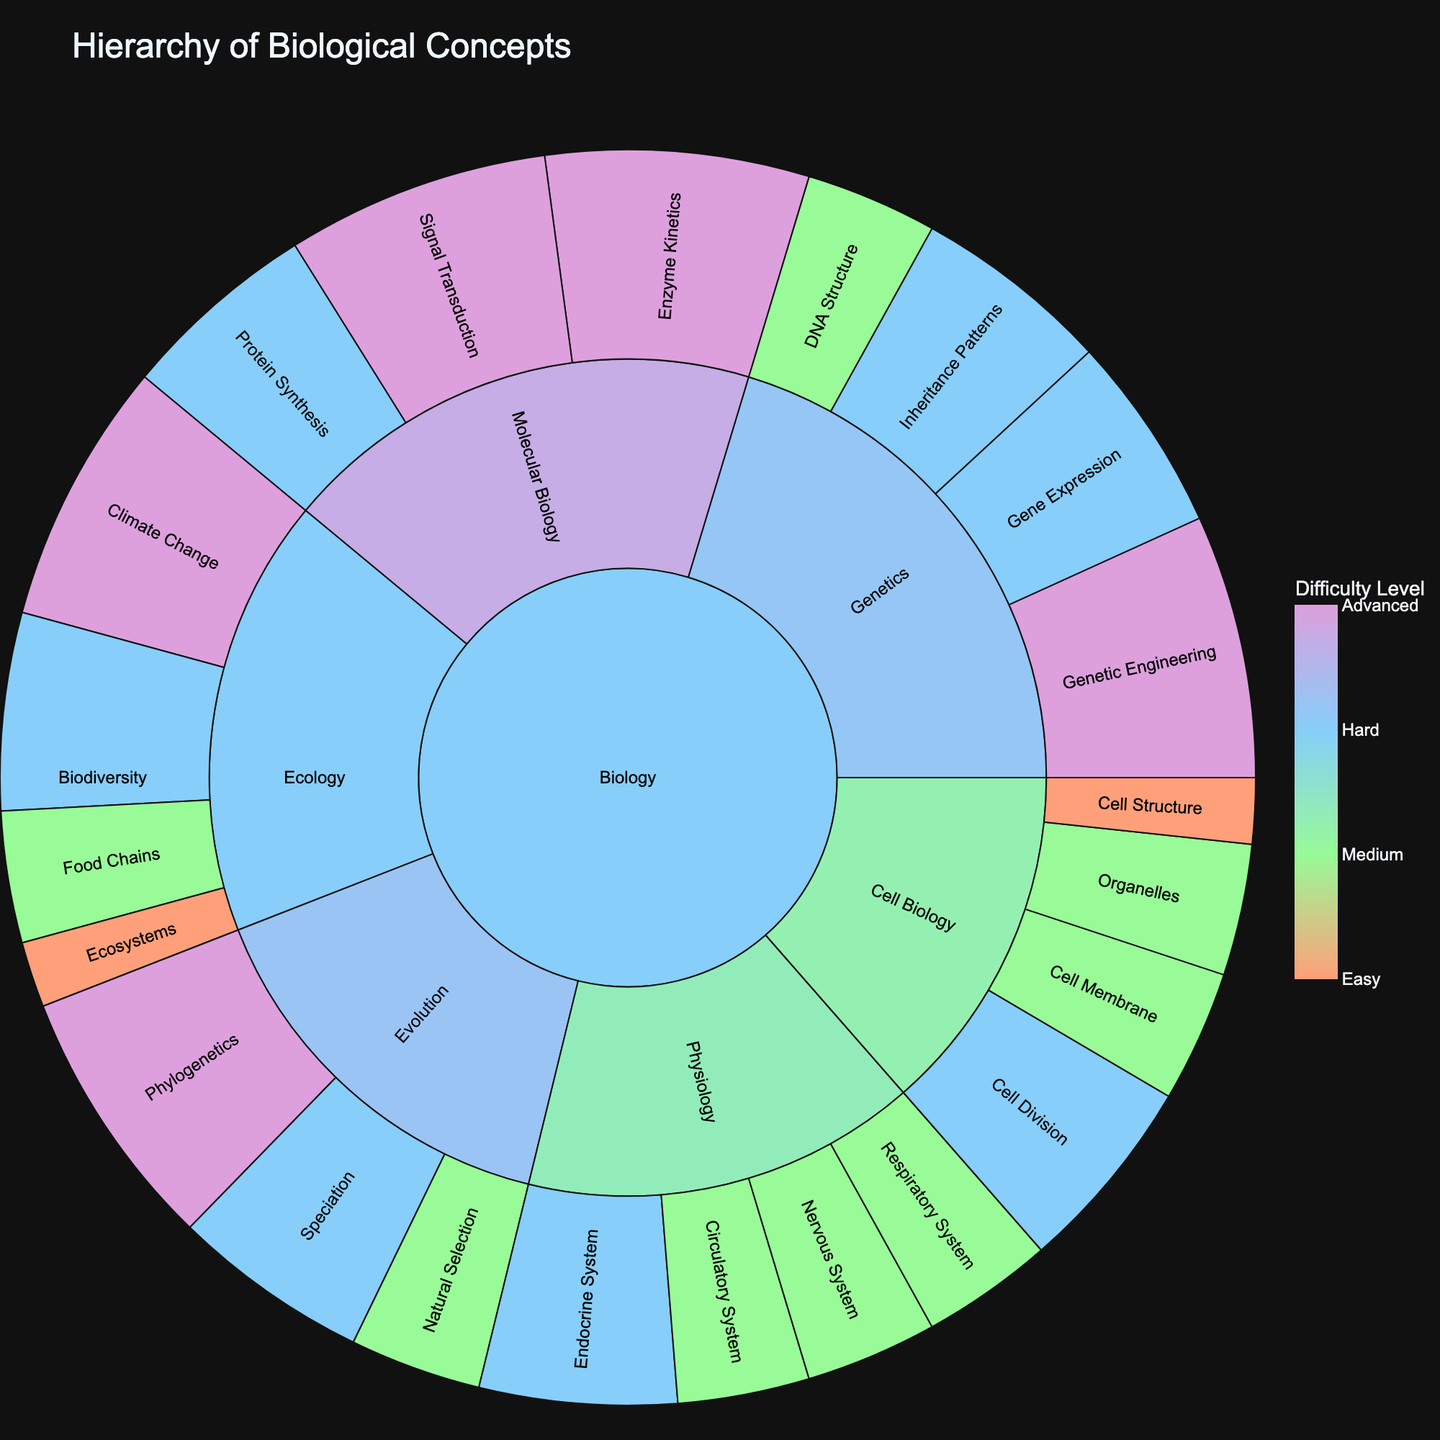What is the title of the plot? The title is usually found at the top of the plot, clearly indicating the subject or purpose of the visualization. Here, it appears as "Hierarchy of Biological Concepts".
Answer: Hierarchy of Biological Concepts How many main subject areas are represented in the plot? By examining the first level of the sunburst plot originating from the center, we see that there is only one main subject area, which is Biology.
Answer: 1 Which category has the most sub-concepts under it? To determine this, observe the categories branching out from the main subject and count the number of sub-concepts within each category. Cell Biology has the most sub-concepts, with 4 sub-concepts.
Answer: Cell Biology What is the highest difficulty level depicted in the plot? By looking at the color scale and the associated segments, we see that the highest difficulty level is labeled as 4, which corresponds to the darkest color in the color scale.
Answer: 4 Which conceptual category under Ecology has the highest difficulty level? Identify the Ecology category, then observe the sub-concepts branching from it and their respective difficulty levels. Climate Change, with a difficulty level of 4, is the highest.
Answer: Climate Change Compare the difficulty levels of concepts in Molecular Biology and Genetics. Which category has more high-difficulty (level 4) concepts? Count the number of segments in each category filled with the color representing difficulty level 4. Molecular Biology has 2 high-difficulty concepts (Enzyme Kinetics and Signal Transduction), while Genetics has 1 (Genetic Engineering).
Answer: Molecular Biology What is the average difficulty level of concepts in Physiology? Calculate the average by summing the difficulty levels of all concepts in Physiology and then dividing by the number of concepts. The concepts are: Nervous System (2), Circulatory System (2), Respiratory System (2), and Endocrine System (3). The total is 9, and there are 4 concepts. So, the average difficulty level is 9/4 = 2.25.
Answer: 2.25 Which visual characteristic in the plot indicates the difficulty level of a concept? The difficulty level of a concept is indicated by its color, adhering to a specific color scale ranging from light (easy) to dark (advanced).
Answer: Color What is the difficulty level of the concept "Gene Expression"? To find the difficulty level of "Gene Expression," locate the Genetics category and then observe the color or look at the hover details for "Gene Expression." The hover details or color will show it as difficulty level 3.
Answer: 3 Under which category does the concept "Protein Synthesis" fall and what is its difficulty level? Locate "Protein Synthesis" within the branches of the sunburst chart. This concept falls under the category of Molecular Biology and has a difficulty level of 3, as indicated by its color and label.
Answer: Molecular Biology, 3 